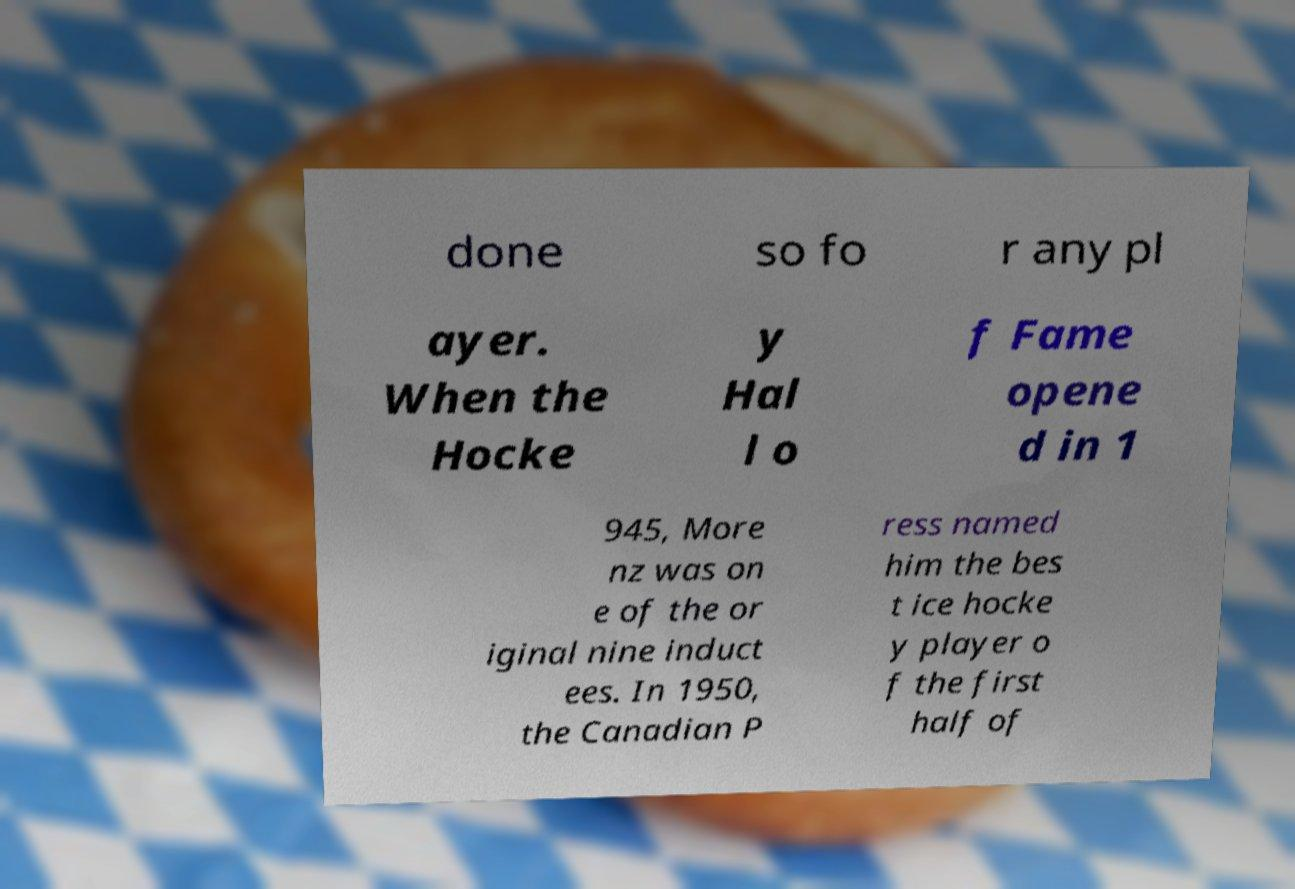Please read and relay the text visible in this image. What does it say? done so fo r any pl ayer. When the Hocke y Hal l o f Fame opene d in 1 945, More nz was on e of the or iginal nine induct ees. In 1950, the Canadian P ress named him the bes t ice hocke y player o f the first half of 